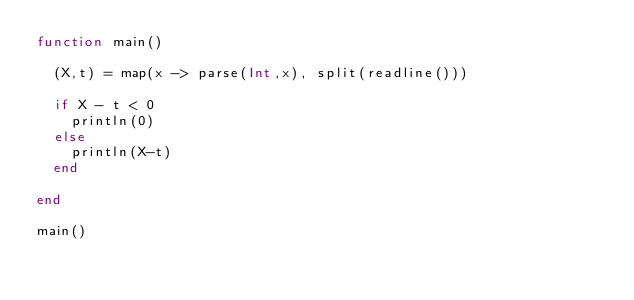<code> <loc_0><loc_0><loc_500><loc_500><_Julia_>function main()
  
  (X,t) = map(x -> parse(Int,x), split(readline()))
  
  if X - t < 0
    println(0)
  else
    println(X-t)
  end
  
end

main()</code> 